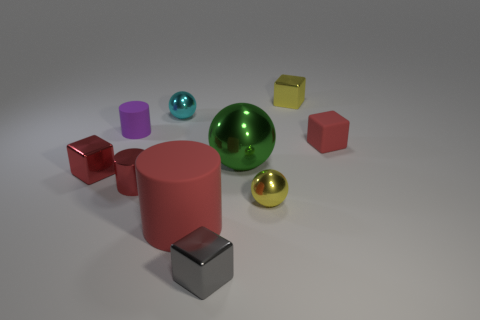There is a large red thing that is the same shape as the small purple rubber thing; what material is it?
Provide a short and direct response. Rubber. There is a big red matte object; what shape is it?
Ensure brevity in your answer.  Cylinder. There is a cube that is behind the tiny gray object and to the left of the large green shiny sphere; what is its material?
Your answer should be compact. Metal. There is a green object that is made of the same material as the cyan ball; what is its shape?
Your response must be concise. Sphere. There is a green sphere that is the same material as the cyan ball; what is its size?
Provide a short and direct response. Large. The matte thing that is right of the metal cylinder and left of the small rubber cube has what shape?
Make the answer very short. Cylinder. There is a matte cylinder behind the small yellow thing in front of the tiny purple rubber object; how big is it?
Ensure brevity in your answer.  Small. How many other things are the same color as the big metallic object?
Provide a succinct answer. 0. What material is the cyan object?
Your answer should be very brief. Metal. Are there any small balls?
Your answer should be compact. Yes. 